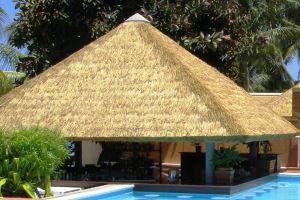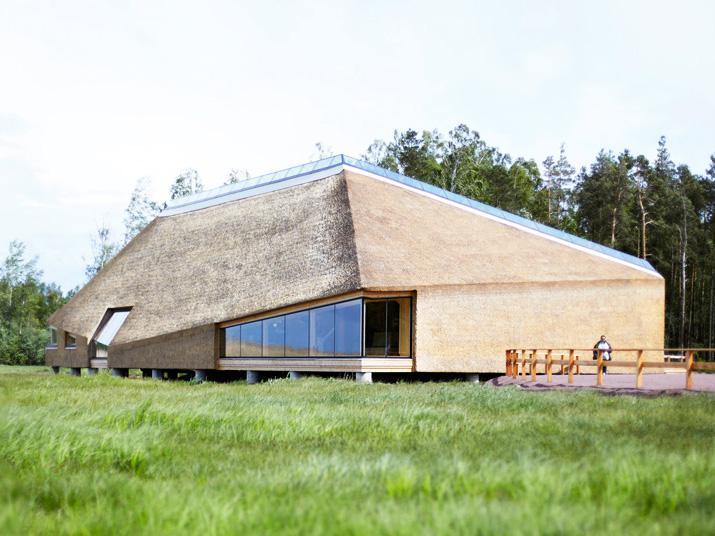The first image is the image on the left, the second image is the image on the right. Considering the images on both sides, is "The left image includes a peaked thatch roof with an even bottom edge and a gray cap on its tip, held up by corner posts." valid? Answer yes or no. Yes. The first image is the image on the left, the second image is the image on the right. For the images shown, is this caption "One of these is an open canopy over a deck area - it's not for dwelling, cooking, or sleeping." true? Answer yes or no. Yes. 